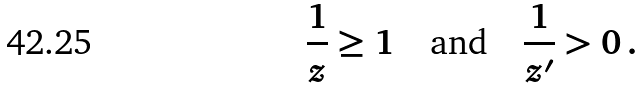<formula> <loc_0><loc_0><loc_500><loc_500>\frac { 1 } { z } \geq 1 \quad \text {and} \quad \frac { 1 } { z ^ { \prime } } > 0 \, .</formula> 